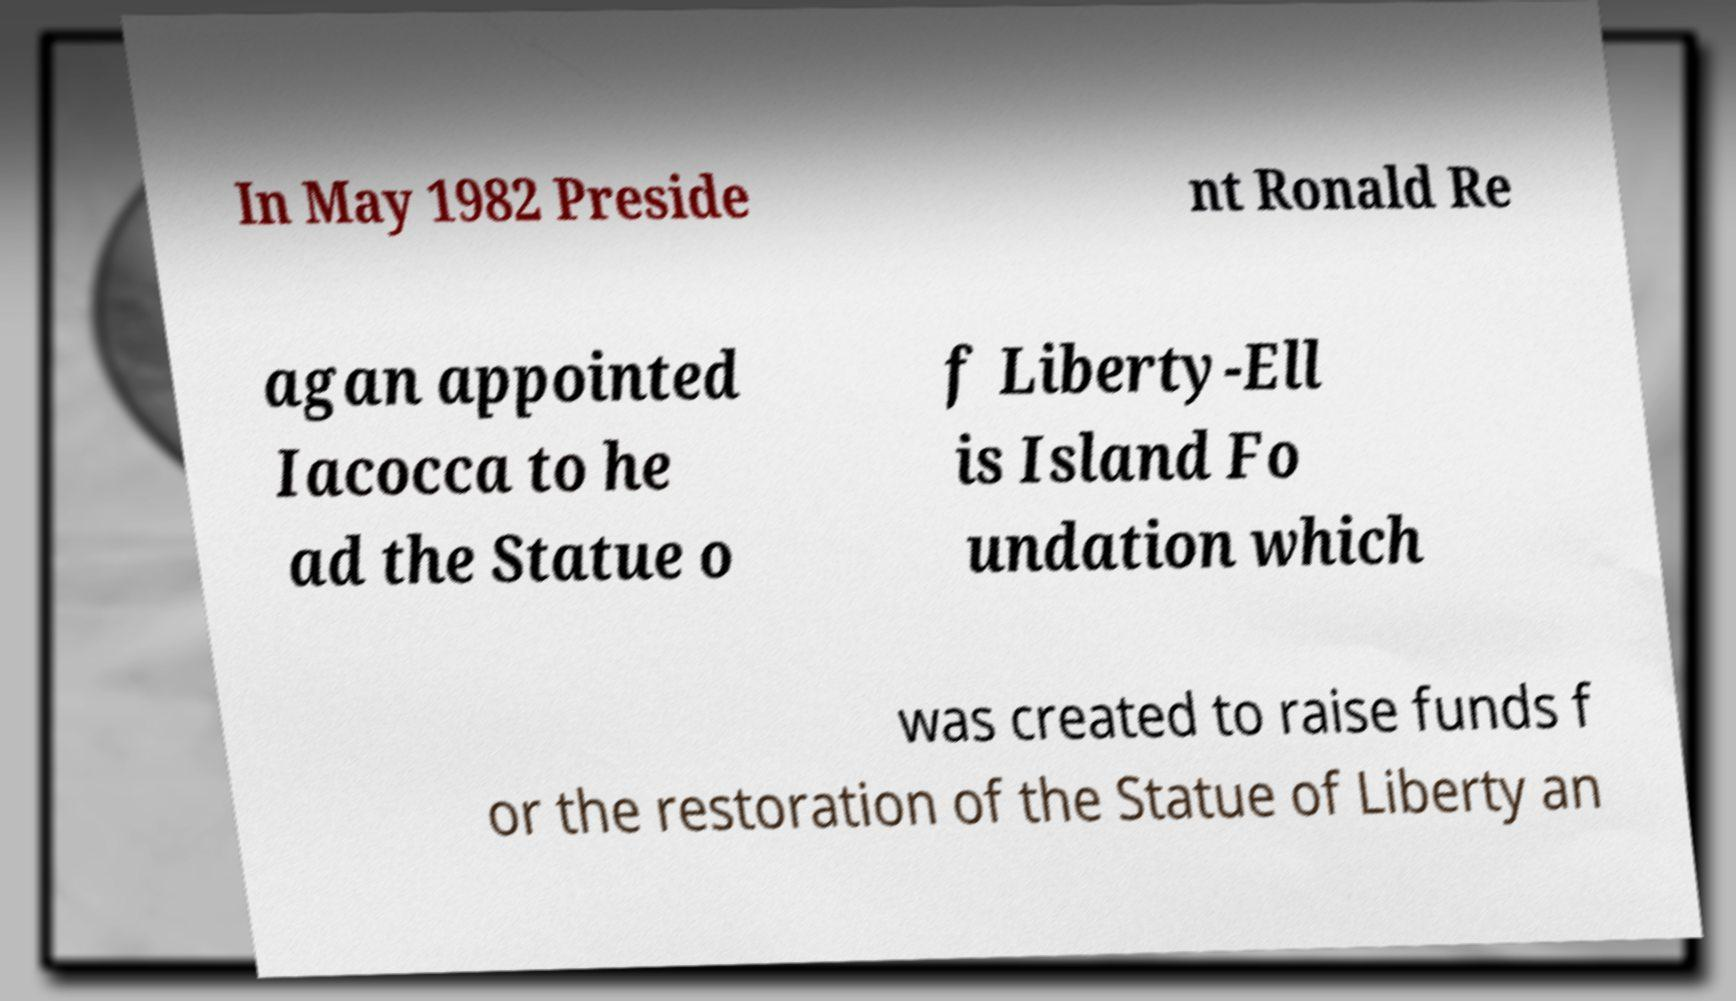Could you extract and type out the text from this image? In May 1982 Preside nt Ronald Re agan appointed Iacocca to he ad the Statue o f Liberty-Ell is Island Fo undation which was created to raise funds f or the restoration of the Statue of Liberty an 